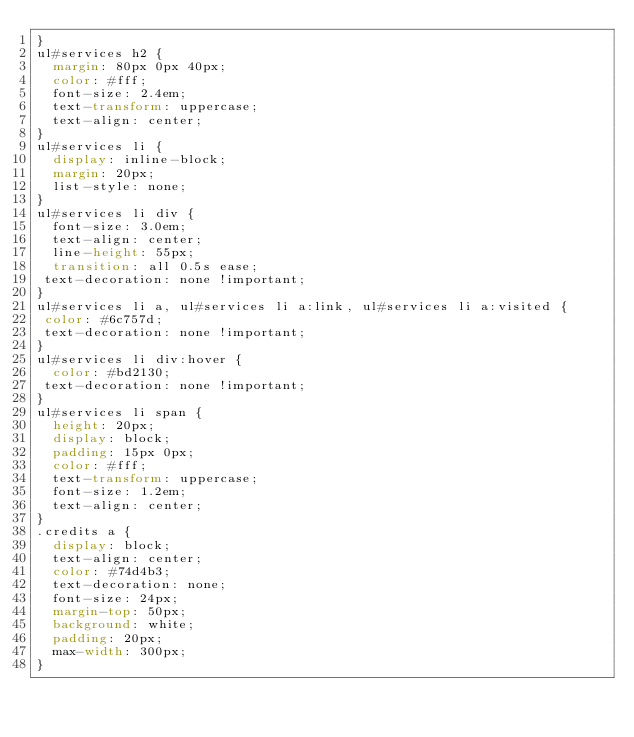Convert code to text. <code><loc_0><loc_0><loc_500><loc_500><_CSS_>}
ul#services h2 {
  margin: 80px 0px 40px;
  color: #fff;
  font-size: 2.4em;
  text-transform: uppercase;
  text-align: center;
}
ul#services li {
  display: inline-block;
  margin: 20px;
  list-style: none;
}
ul#services li div {
  font-size: 3.0em;
  text-align: center;
  line-height: 55px;
  transition: all 0.5s ease;
 text-decoration: none !important;  
}
ul#services li a, ul#services li a:link, ul#services li a:visited {
 color: #6c757d; 
 text-decoration: none !important;  
}
ul#services li div:hover {
  color: #bd2130;
 text-decoration: none !important;  
}
ul#services li span {
  height: 20px;
  display: block;
  padding: 15px 0px;
  color: #fff;
  text-transform: uppercase;
  font-size: 1.2em;
  text-align: center;
}
.credits a {
  display: block;
  text-align: center;
  color: #74d4b3;
  text-decoration: none;
  font-size: 24px;
  margin-top: 50px;
  background: white;
  padding: 20px;
  max-width: 300px;
}



</code> 